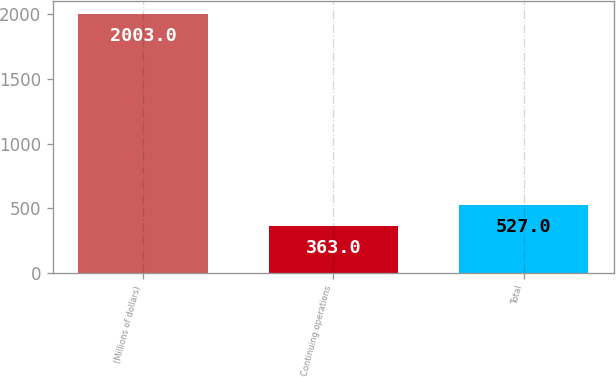Convert chart. <chart><loc_0><loc_0><loc_500><loc_500><bar_chart><fcel>(Millions of dollars)<fcel>Continuing operations<fcel>Total<nl><fcel>2003<fcel>363<fcel>527<nl></chart> 